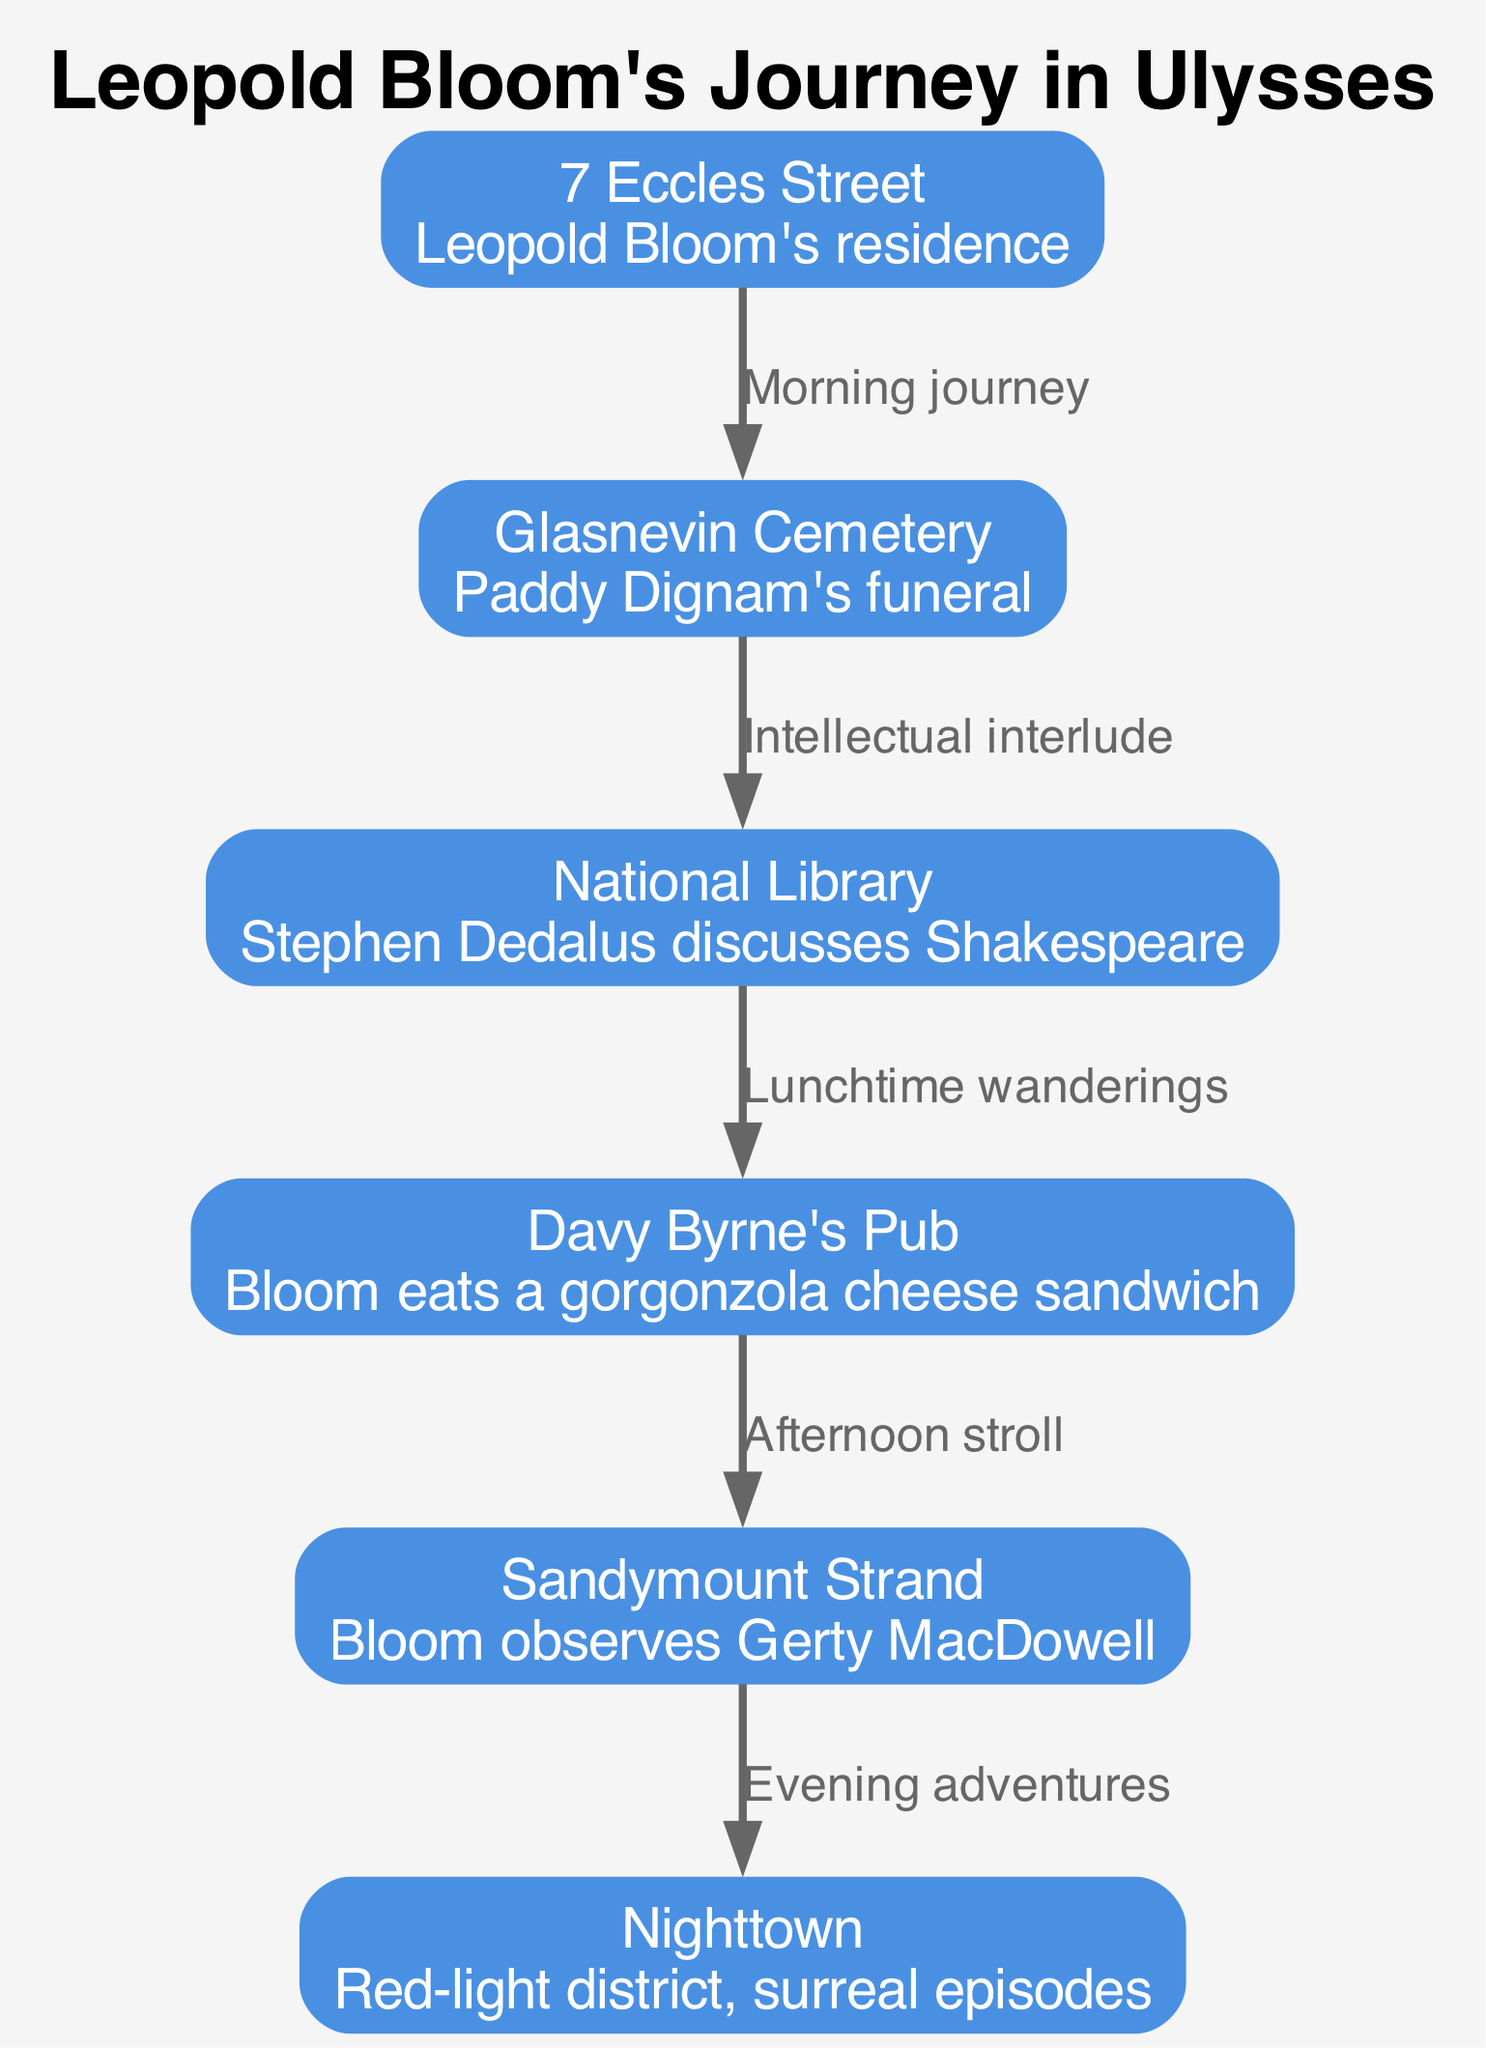What is the starting point of Leopold Bloom's journey? The starting node in the diagram is "7 Eccles Street," identified as Leopold Bloom's residence. It is the first node displayed in the path sequence.
Answer: 7 Eccles Street How many nodes are depicted in the diagram? By counting each unique location identified by the nodes, we find there are six locations mentioned: 7 Eccles Street, Glasnevin Cemetery, National Library, Davy Byrne's Pub, Sandymount Strand, and Nighttown.
Answer: 6 What does Bloom do at Davy Byrne's Pub? The description of the node "Davy Byrne's Pub" states that Bloom eats a gorgonzola cheese sandwich, pointing to a specific activity at this location.
Answer: Eats a gorgonzola cheese sandwich Which two locations are connected by the label "Afternoon stroll"? According to the edge connections in the diagram, the locations connected by this label are "Davy Byrne's Pub" and "Sandymount Strand," indicating the transition during the afternoon in Bloom's journey.
Answer: Davy Byrne's Pub and Sandymount Strand What is the significance of Nighttown in Bloom's journey? "Nighttown" is characterized as the red-light district where surreal episodes occur. This information adds an element of both location and thematic depth to Bloom’s evening adventures.
Answer: Red-light district, surreal episodes What comes after the intellectual interlude at the National Library? Following the connection labeled "Intellectual interlude," the path goes from the "National Library" to "Davy Byrne's Pub," indicating the next stop in Bloom's journey after engaging with Stephen Dedalus.
Answer: Davy Byrne's Pub List the sequence of locations Bloom visits from morning to evening. By following the arrows of the edges, the sequence starts from "7 Eccles Street," goes to "Glasnevin Cemetery," then "National Library," moves to "Davy Byrne's Pub," continues to "Sandymount Strand," and ends at "Nighttown."
Answer: 7 Eccles Street, Glasnevin Cemetery, National Library, Davy Byrne's Pub, Sandymount Strand, Nighttown 